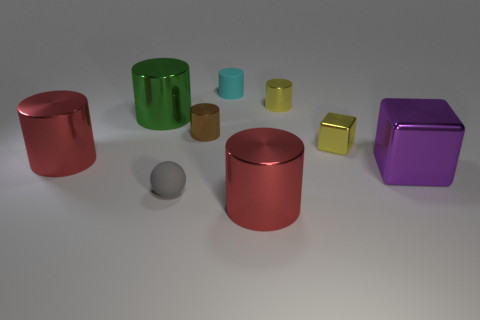Subtract 2 cylinders. How many cylinders are left? 4 Subtract all yellow cylinders. How many cylinders are left? 5 Subtract all red cylinders. How many cylinders are left? 4 Subtract all purple cylinders. Subtract all red balls. How many cylinders are left? 6 Subtract all balls. How many objects are left? 8 Add 4 matte cylinders. How many matte cylinders exist? 5 Subtract 0 purple cylinders. How many objects are left? 9 Subtract all small cyan things. Subtract all spheres. How many objects are left? 7 Add 1 tiny metal things. How many tiny metal things are left? 4 